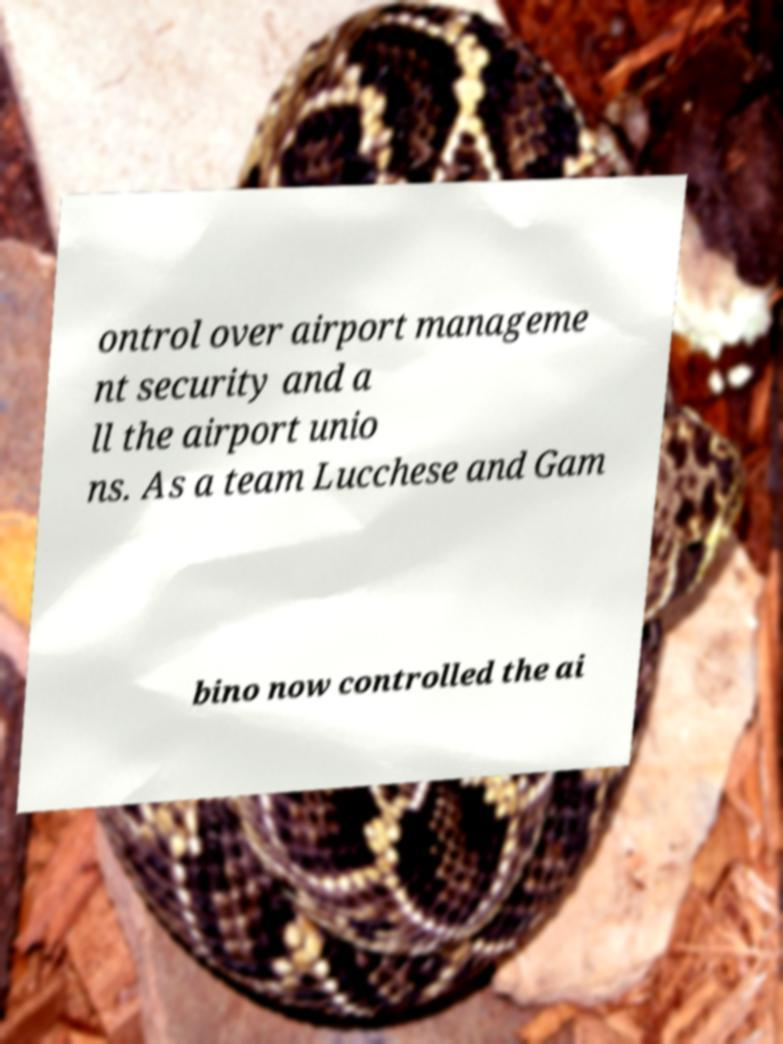Could you assist in decoding the text presented in this image and type it out clearly? ontrol over airport manageme nt security and a ll the airport unio ns. As a team Lucchese and Gam bino now controlled the ai 